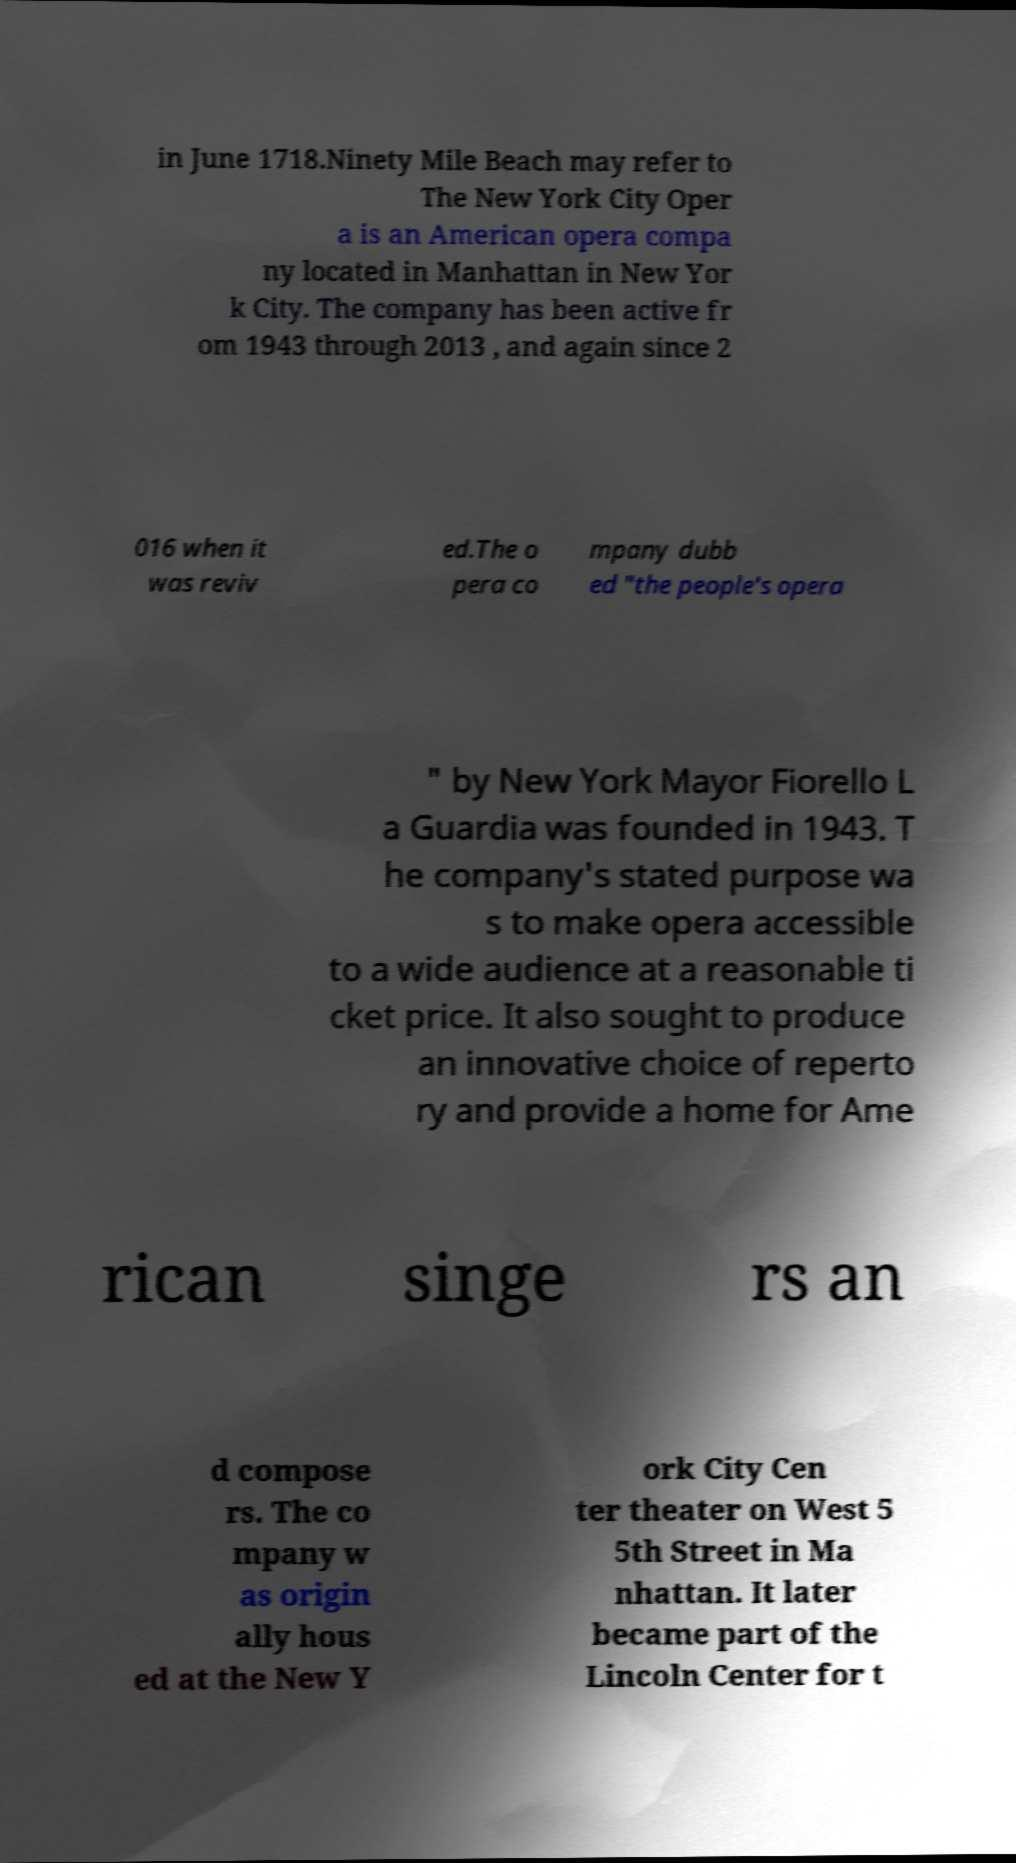There's text embedded in this image that I need extracted. Can you transcribe it verbatim? in June 1718.Ninety Mile Beach may refer to The New York City Oper a is an American opera compa ny located in Manhattan in New Yor k City. The company has been active fr om 1943 through 2013 , and again since 2 016 when it was reviv ed.The o pera co mpany dubb ed "the people's opera " by New York Mayor Fiorello L a Guardia was founded in 1943. T he company's stated purpose wa s to make opera accessible to a wide audience at a reasonable ti cket price. It also sought to produce an innovative choice of reperto ry and provide a home for Ame rican singe rs an d compose rs. The co mpany w as origin ally hous ed at the New Y ork City Cen ter theater on West 5 5th Street in Ma nhattan. It later became part of the Lincoln Center for t 